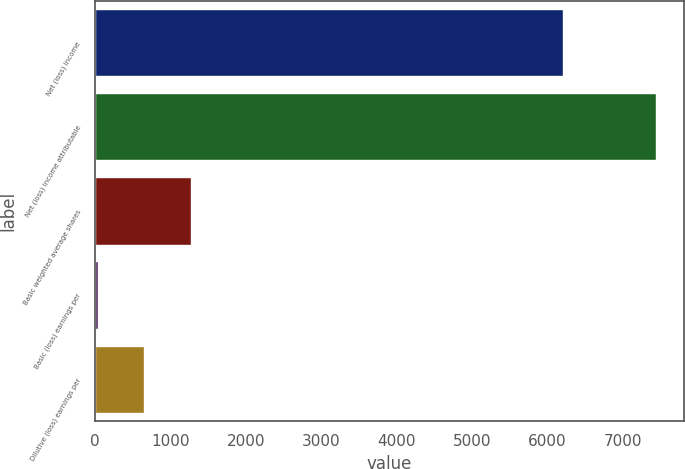<chart> <loc_0><loc_0><loc_500><loc_500><bar_chart><fcel>Net (loss) income<fcel>Net (loss) income attributable<fcel>Basic weighted average shares<fcel>Basic (loss) earnings per<fcel>Dilutive (loss) earnings per<nl><fcel>6203<fcel>7437.68<fcel>1266.26<fcel>31.58<fcel>648.92<nl></chart> 